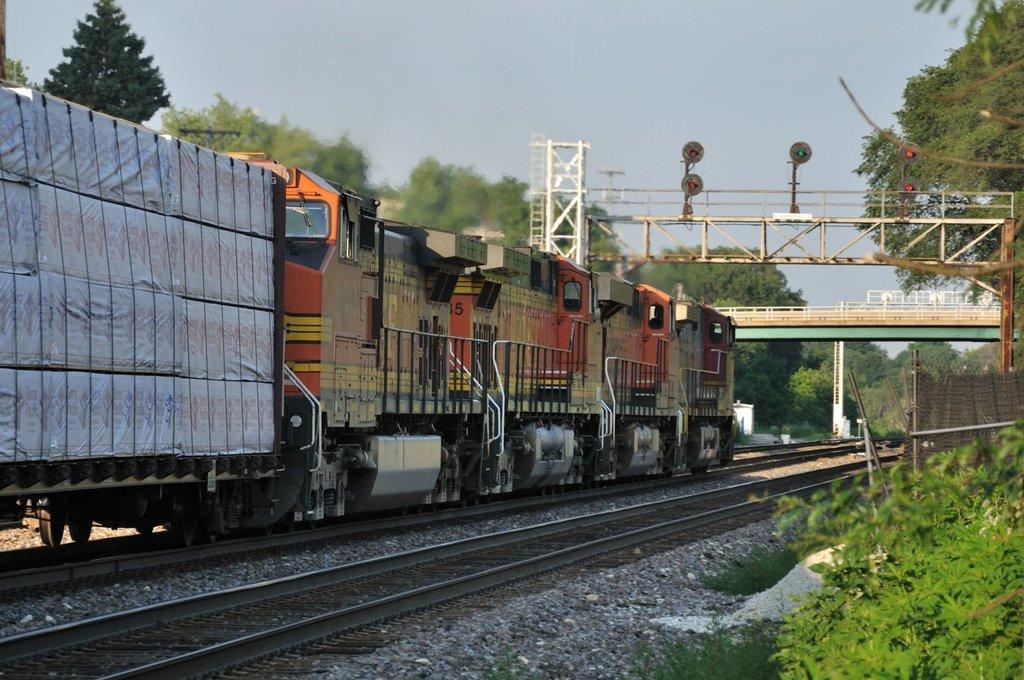Could you give a brief overview of what you see in this image? This image consists of a train. At the bottom, there are tracks along with stones. On the right, we can see small plants. On the left and right, there are trees. In the middle, we can see a bridge and a stand alone with signal lights. At the top, there is sky. 